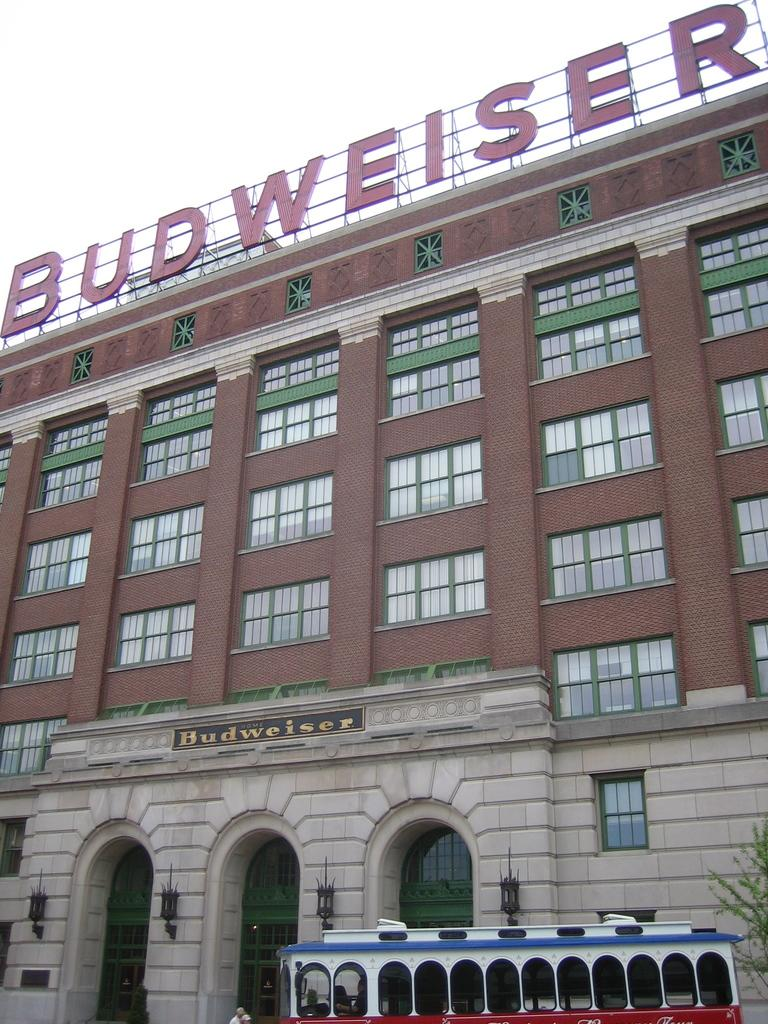What is the main structure in the center of the image? There is a building in the center of the image. What can be seen at the bottom of the image? A: There is a bus and a tree at the bottom of the image. Are there any people visible in the image? Yes, people are visible in the image. What is visible at the top of the image? There is sky visible at the top of the image. What language are the sisters speaking in the lunchroom in the image? There are no sisters or lunchroom present in the image. 